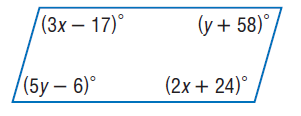Question: Find y so that the quadrilateral is a parallelogram.
Choices:
A. 16
B. 32
C. 74
D. 80
Answer with the letter. Answer: A 